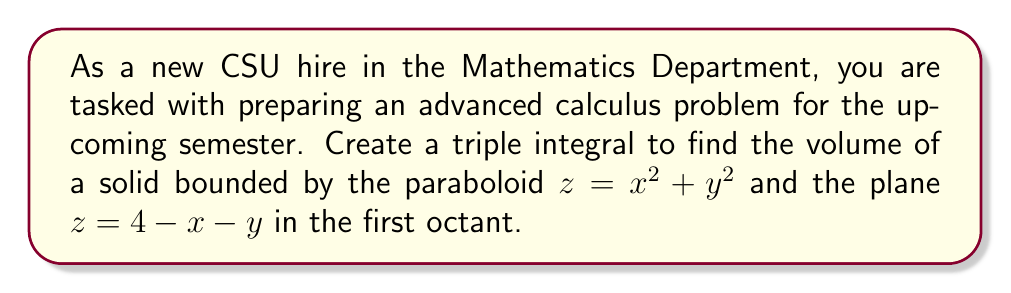Could you help me with this problem? Let's approach this step-by-step:

1) First, we need to determine the region of integration. The solid is bounded by two surfaces:
   $z = x^2 + y^2$ (paraboloid)
   $z = 4 - x - y$ (plane)

2) The intersection of these surfaces occurs when:
   $x^2 + y^2 = 4 - x - y$

3) We're only interested in the first octant, so $x \geq 0$, $y \geq 0$, and $z \geq 0$.

4) To set up the triple integral, we'll integrate z first, then y, then x:

   $$V = \int_{0}^{a}\int_{0}^{b}\int_{x^2+y^2}^{4-x-y} dz dy dx$$

   Where $a$ and $b$ are the limits of x and y respectively, which we need to determine.

5) To find $a$ and $b$, we need to project the intersection curve onto the xy-plane:
   $x^2 + y^2 + x + y = 4$
   $(x + \frac{1}{2})^2 + (y + \frac{1}{2})^2 = \frac{25}{4}$

   This is a circle with center $(-\frac{1}{2}, -\frac{1}{2})$ and radius $\frac{5}{2}$.

6) In the first quadrant, the x-intercept of this circle (which is our $a$) is:
   $a = \frac{5}{2} - \frac{1}{2} = 2$

7) For each x, y ranges from 0 to the y-value on the circle:
   $b = \sqrt{\frac{25}{4} - (x + \frac{1}{2})^2} - \frac{1}{2}$

8) Now we can set up our triple integral:

   $$V = \int_{0}^{2}\int_{0}^{\sqrt{\frac{25}{4} - (x + \frac{1}{2})^2} - \frac{1}{2}}\int_{x^2+y^2}^{4-x-y} dz dy dx$$

9) Evaluating the innermost integral:

   $$V = \int_{0}^{2}\int_{0}^{\sqrt{\frac{25}{4} - (x + \frac{1}{2})^2} - \frac{1}{2}} (4-x-y) - (x^2+y^2) dy dx$$

10) This double integral can be evaluated using numerical methods or computer algebra systems due to its complexity.

11) After evaluation, the result is $\frac{2\pi}{3}$ cubic units.
Answer: $\frac{2\pi}{3}$ cubic units 